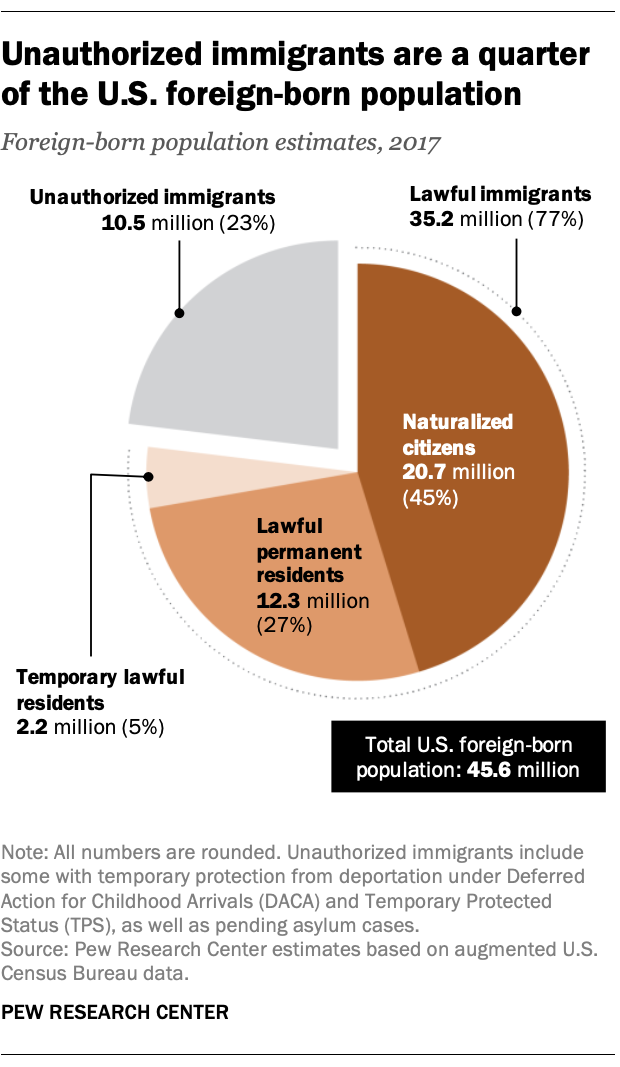Point out several critical features in this image. The overall percentage of dark brown and gray in the mixture is 68%. Naturalized citizens hold the greatest monetary value among the listed shares, 